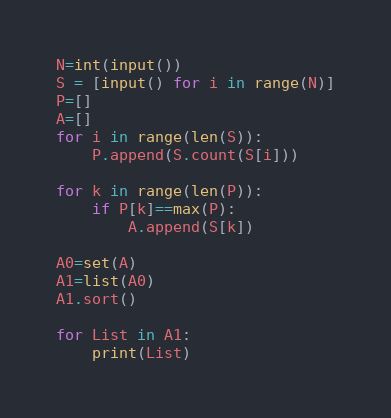<code> <loc_0><loc_0><loc_500><loc_500><_Python_>N=int(input())
S = [input() for i in range(N)]
P=[]
A=[]
for i in range(len(S)):
    P.append(S.count(S[i]))

for k in range(len(P)):
    if P[k]==max(P):
        A.append(S[k])

A0=set(A)
A1=list(A0)
A1.sort()

for List in A1:
    print(List)</code> 